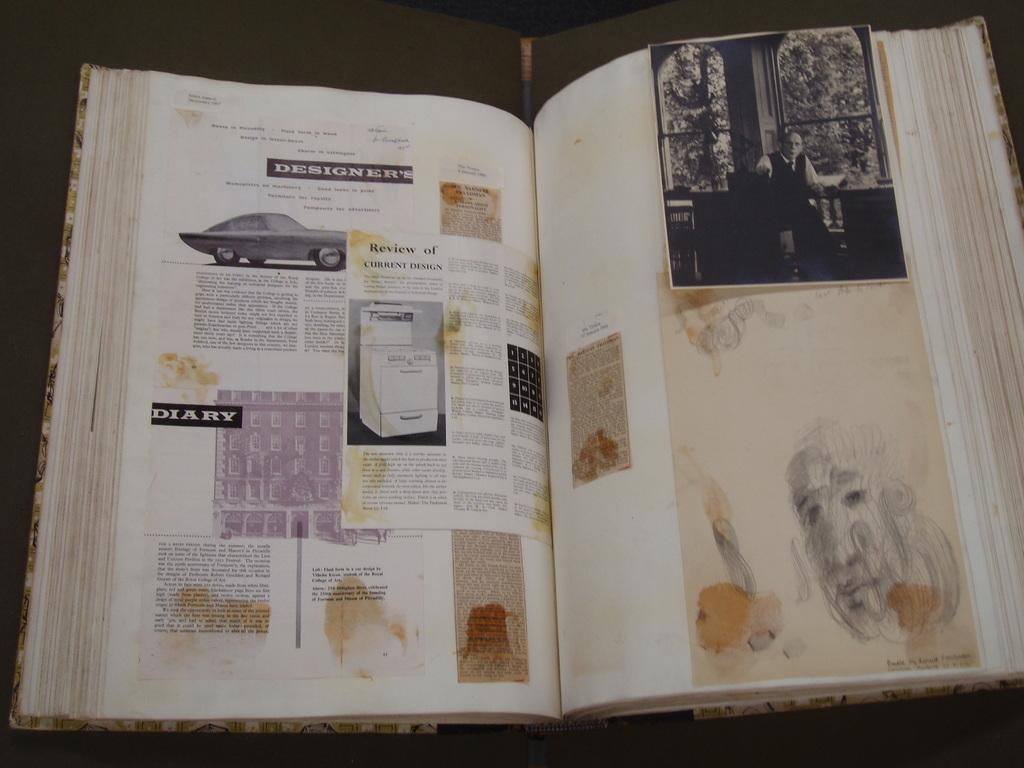<image>
Present a compact description of the photo's key features. a book has the word diary on the front of it 